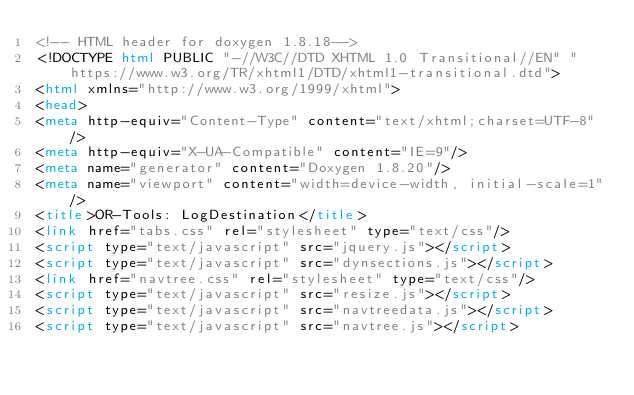<code> <loc_0><loc_0><loc_500><loc_500><_HTML_><!-- HTML header for doxygen 1.8.18-->
<!DOCTYPE html PUBLIC "-//W3C//DTD XHTML 1.0 Transitional//EN" "https://www.w3.org/TR/xhtml1/DTD/xhtml1-transitional.dtd">
<html xmlns="http://www.w3.org/1999/xhtml">
<head>
<meta http-equiv="Content-Type" content="text/xhtml;charset=UTF-8"/>
<meta http-equiv="X-UA-Compatible" content="IE=9"/>
<meta name="generator" content="Doxygen 1.8.20"/>
<meta name="viewport" content="width=device-width, initial-scale=1"/>
<title>OR-Tools: LogDestination</title>
<link href="tabs.css" rel="stylesheet" type="text/css"/>
<script type="text/javascript" src="jquery.js"></script>
<script type="text/javascript" src="dynsections.js"></script>
<link href="navtree.css" rel="stylesheet" type="text/css"/>
<script type="text/javascript" src="resize.js"></script>
<script type="text/javascript" src="navtreedata.js"></script>
<script type="text/javascript" src="navtree.js"></script></code> 